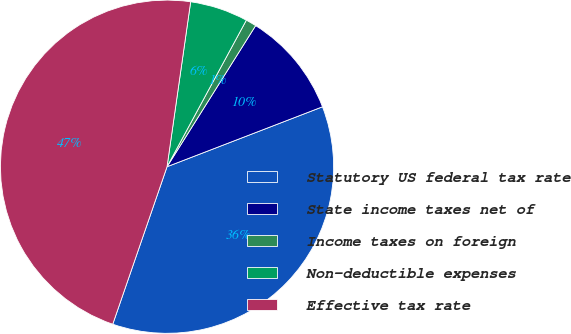<chart> <loc_0><loc_0><loc_500><loc_500><pie_chart><fcel>Statutory US federal tax rate<fcel>State income taxes net of<fcel>Income taxes on foreign<fcel>Non-deductible expenses<fcel>Effective tax rate<nl><fcel>36.14%<fcel>10.22%<fcel>1.03%<fcel>5.63%<fcel>46.98%<nl></chart> 